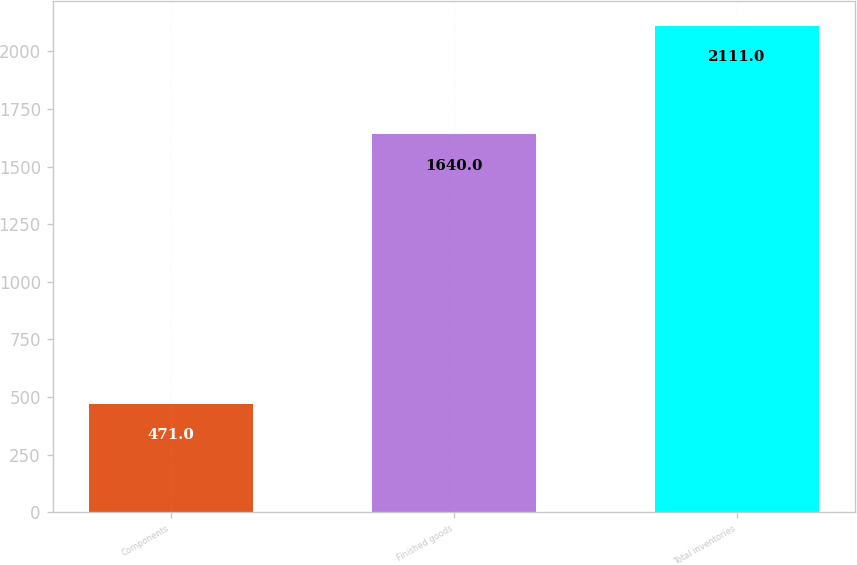Convert chart to OTSL. <chart><loc_0><loc_0><loc_500><loc_500><bar_chart><fcel>Components<fcel>Finished goods<fcel>Total inventories<nl><fcel>471<fcel>1640<fcel>2111<nl></chart> 